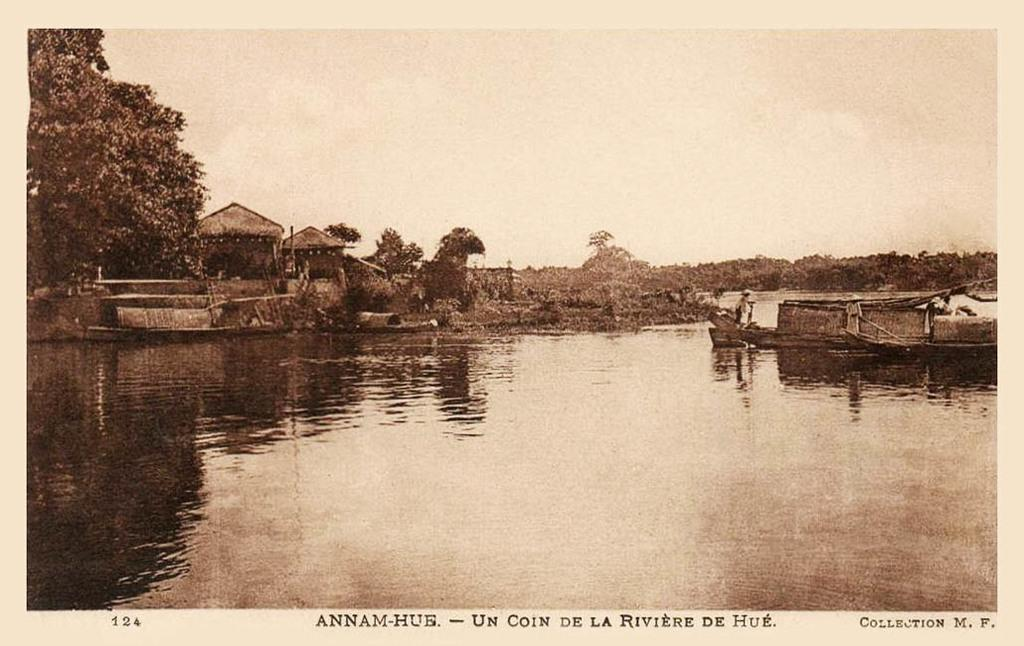What is the color scheme of the image? The image is black and white. What can be seen on the river in the image? There are boats on the river in the image. What is located on the left side of the image? There are trees and houses on the left side of the image. What is visible in the background of the image? There is a sky visible in the background of the image. What type of jelly is being served in the bedroom in the image? There is no jelly or bedroom present in the image; it features a river with boats, trees, houses, and a sky. Which direction is the north indicated in the image? The image does not have any specific directional indicators, such as a compass or a map, to determine the north. 